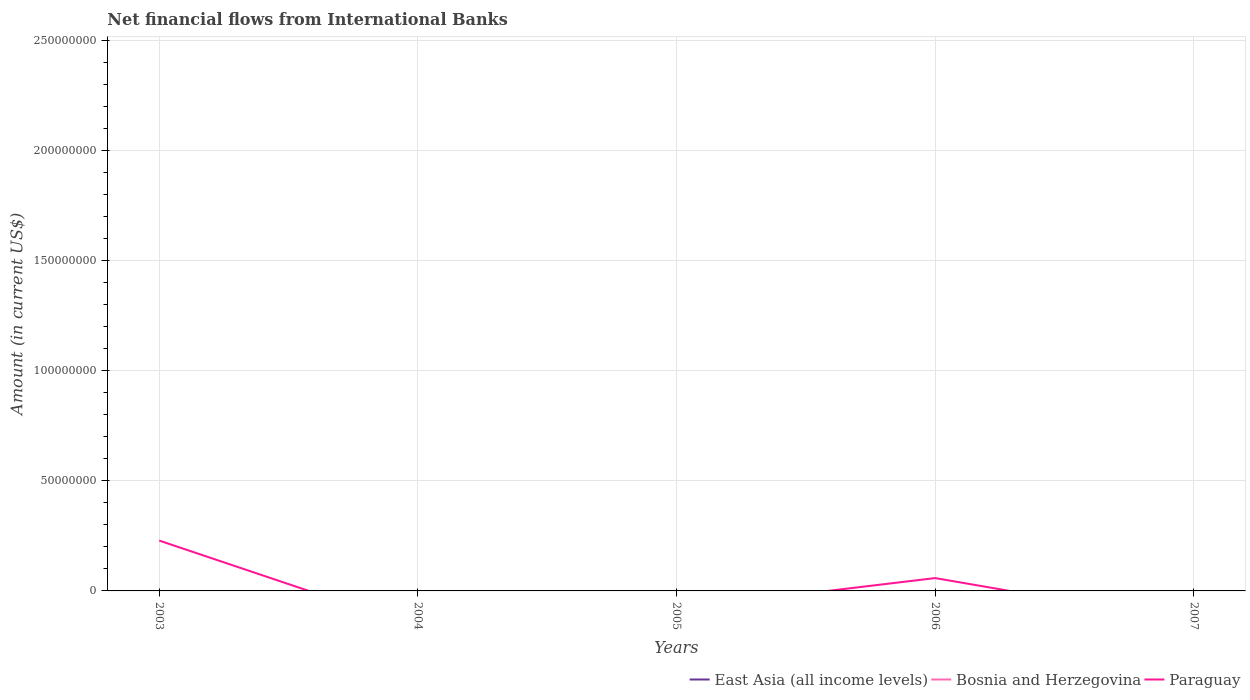Does the line corresponding to Bosnia and Herzegovina intersect with the line corresponding to Paraguay?
Your answer should be very brief. No. Is the number of lines equal to the number of legend labels?
Offer a very short reply. No. What is the total net financial aid flows in Paraguay in the graph?
Offer a terse response. 1.70e+07. What is the difference between the highest and the second highest net financial aid flows in Paraguay?
Provide a short and direct response. 2.29e+07. Is the net financial aid flows in Bosnia and Herzegovina strictly greater than the net financial aid flows in East Asia (all income levels) over the years?
Your answer should be compact. No. How many lines are there?
Offer a very short reply. 1. How many years are there in the graph?
Give a very brief answer. 5. What is the difference between two consecutive major ticks on the Y-axis?
Provide a short and direct response. 5.00e+07. Are the values on the major ticks of Y-axis written in scientific E-notation?
Offer a very short reply. No. How many legend labels are there?
Offer a very short reply. 3. How are the legend labels stacked?
Provide a succinct answer. Horizontal. What is the title of the graph?
Keep it short and to the point. Net financial flows from International Banks. What is the label or title of the X-axis?
Offer a very short reply. Years. What is the label or title of the Y-axis?
Provide a succinct answer. Amount (in current US$). What is the Amount (in current US$) in East Asia (all income levels) in 2003?
Make the answer very short. 0. What is the Amount (in current US$) of Bosnia and Herzegovina in 2003?
Your answer should be very brief. 0. What is the Amount (in current US$) of Paraguay in 2003?
Offer a terse response. 2.29e+07. What is the Amount (in current US$) in Bosnia and Herzegovina in 2004?
Your response must be concise. 0. What is the Amount (in current US$) in Paraguay in 2004?
Make the answer very short. 0. What is the Amount (in current US$) in East Asia (all income levels) in 2005?
Your answer should be compact. 0. What is the Amount (in current US$) in Bosnia and Herzegovina in 2005?
Provide a short and direct response. 0. What is the Amount (in current US$) in Paraguay in 2005?
Your answer should be very brief. 0. What is the Amount (in current US$) in Bosnia and Herzegovina in 2006?
Keep it short and to the point. 0. What is the Amount (in current US$) in Paraguay in 2006?
Provide a short and direct response. 5.84e+06. What is the Amount (in current US$) in East Asia (all income levels) in 2007?
Ensure brevity in your answer.  0. What is the Amount (in current US$) of Bosnia and Herzegovina in 2007?
Offer a very short reply. 0. Across all years, what is the maximum Amount (in current US$) in Paraguay?
Keep it short and to the point. 2.29e+07. Across all years, what is the minimum Amount (in current US$) of Paraguay?
Your answer should be very brief. 0. What is the total Amount (in current US$) in Bosnia and Herzegovina in the graph?
Make the answer very short. 0. What is the total Amount (in current US$) of Paraguay in the graph?
Make the answer very short. 2.87e+07. What is the difference between the Amount (in current US$) in Paraguay in 2003 and that in 2006?
Offer a very short reply. 1.70e+07. What is the average Amount (in current US$) of Bosnia and Herzegovina per year?
Provide a succinct answer. 0. What is the average Amount (in current US$) of Paraguay per year?
Offer a terse response. 5.74e+06. What is the ratio of the Amount (in current US$) in Paraguay in 2003 to that in 2006?
Make the answer very short. 3.92. What is the difference between the highest and the lowest Amount (in current US$) in Paraguay?
Your response must be concise. 2.29e+07. 